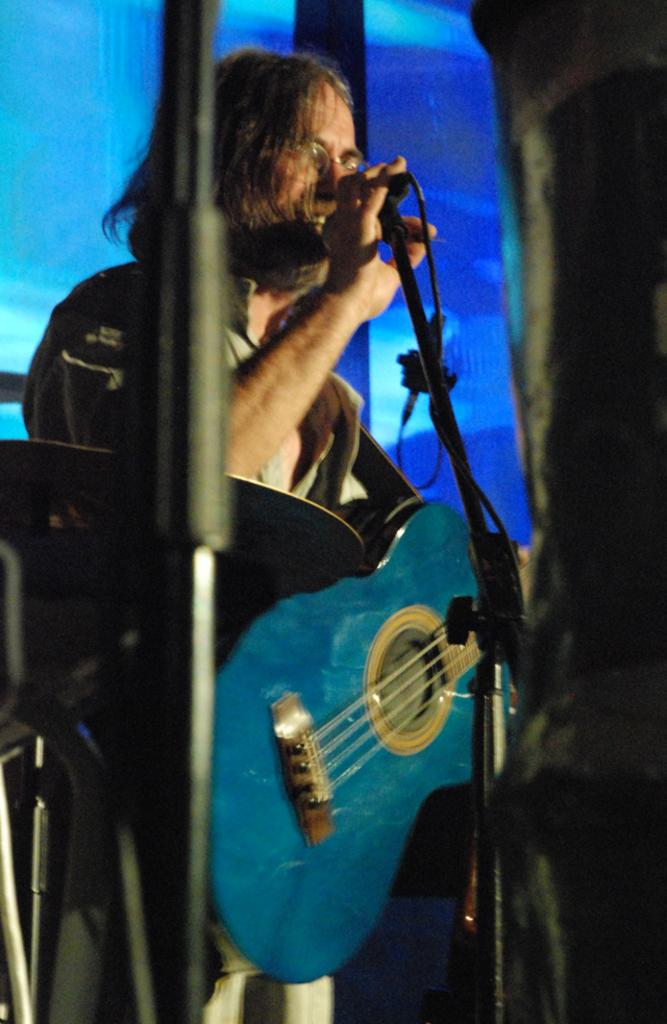What is the main subject of the image? There is a man in the image. What is the man doing in the image? The man is standing, singing, and holding a microphone and a guitar. What other musical instruments can be seen in the image? There are drums visible in the image. What type of coal is being used to fuel the man's performance in the image? There is no coal present in the image, and it does not depict any performance being fueled by coal. 